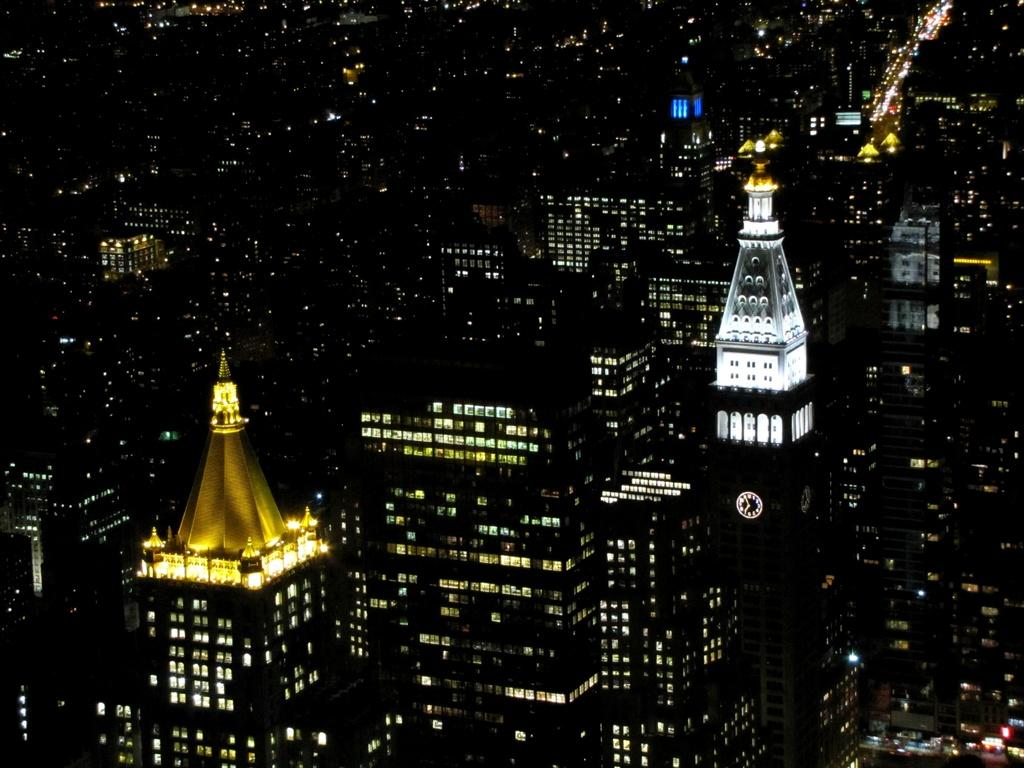What type of structures are visible in the image? There is a group of buildings in the image. What feature do the buildings have? The buildings have lights. Can you describe a specific detail about one of the buildings? There is a clock on a tower in the image. What type of bushes can be seen growing near the oil well in the image? There is no mention of bushes or oil wells in the image; it features a group of buildings with lights and a clock on a tower. 